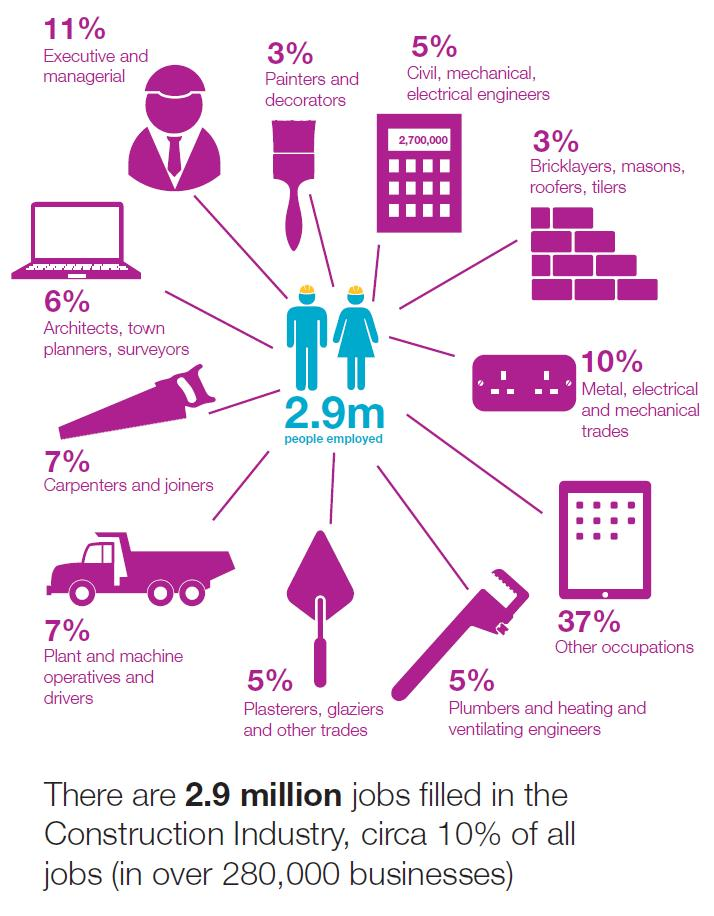Indicate a few pertinent items in this graphic. The saw indicates the category of carpenters and joiners. According to estimates, only 3% of the people employed are painters and decorators. In total, 6% of employed individuals are architects, town planners, and surveyors. Thirty-seven percent of individuals do not have their occupation defined. The group of individuals who have the same percentage as plant and machine operatives and drivers is carpenters and joiners. 